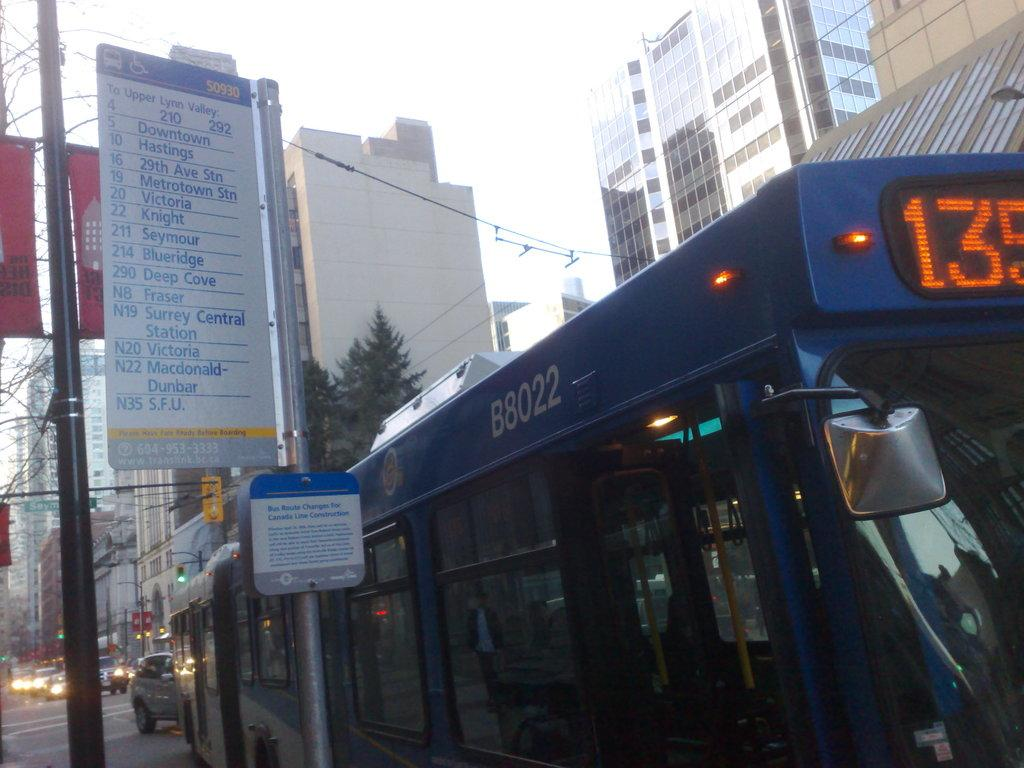<image>
Share a concise interpretation of the image provided. Blue bus with the plate B8022 on it parked. 